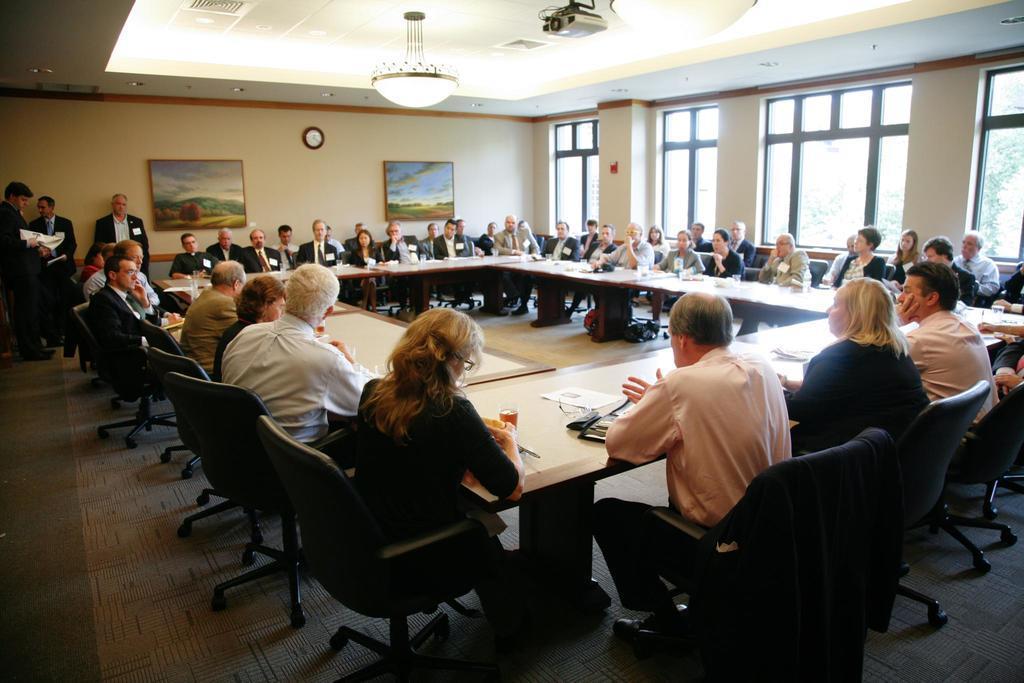Describe this image in one or two sentences. In the foreground of this image, there are people sitting around the table on the chairs. We can also see few objects on the table. On the left, there are three men standing on the floor. In the background, there are frames and a clock on the wall. In the right background, there are windows. At the top, there is a chandelier, few lights and a projector. 